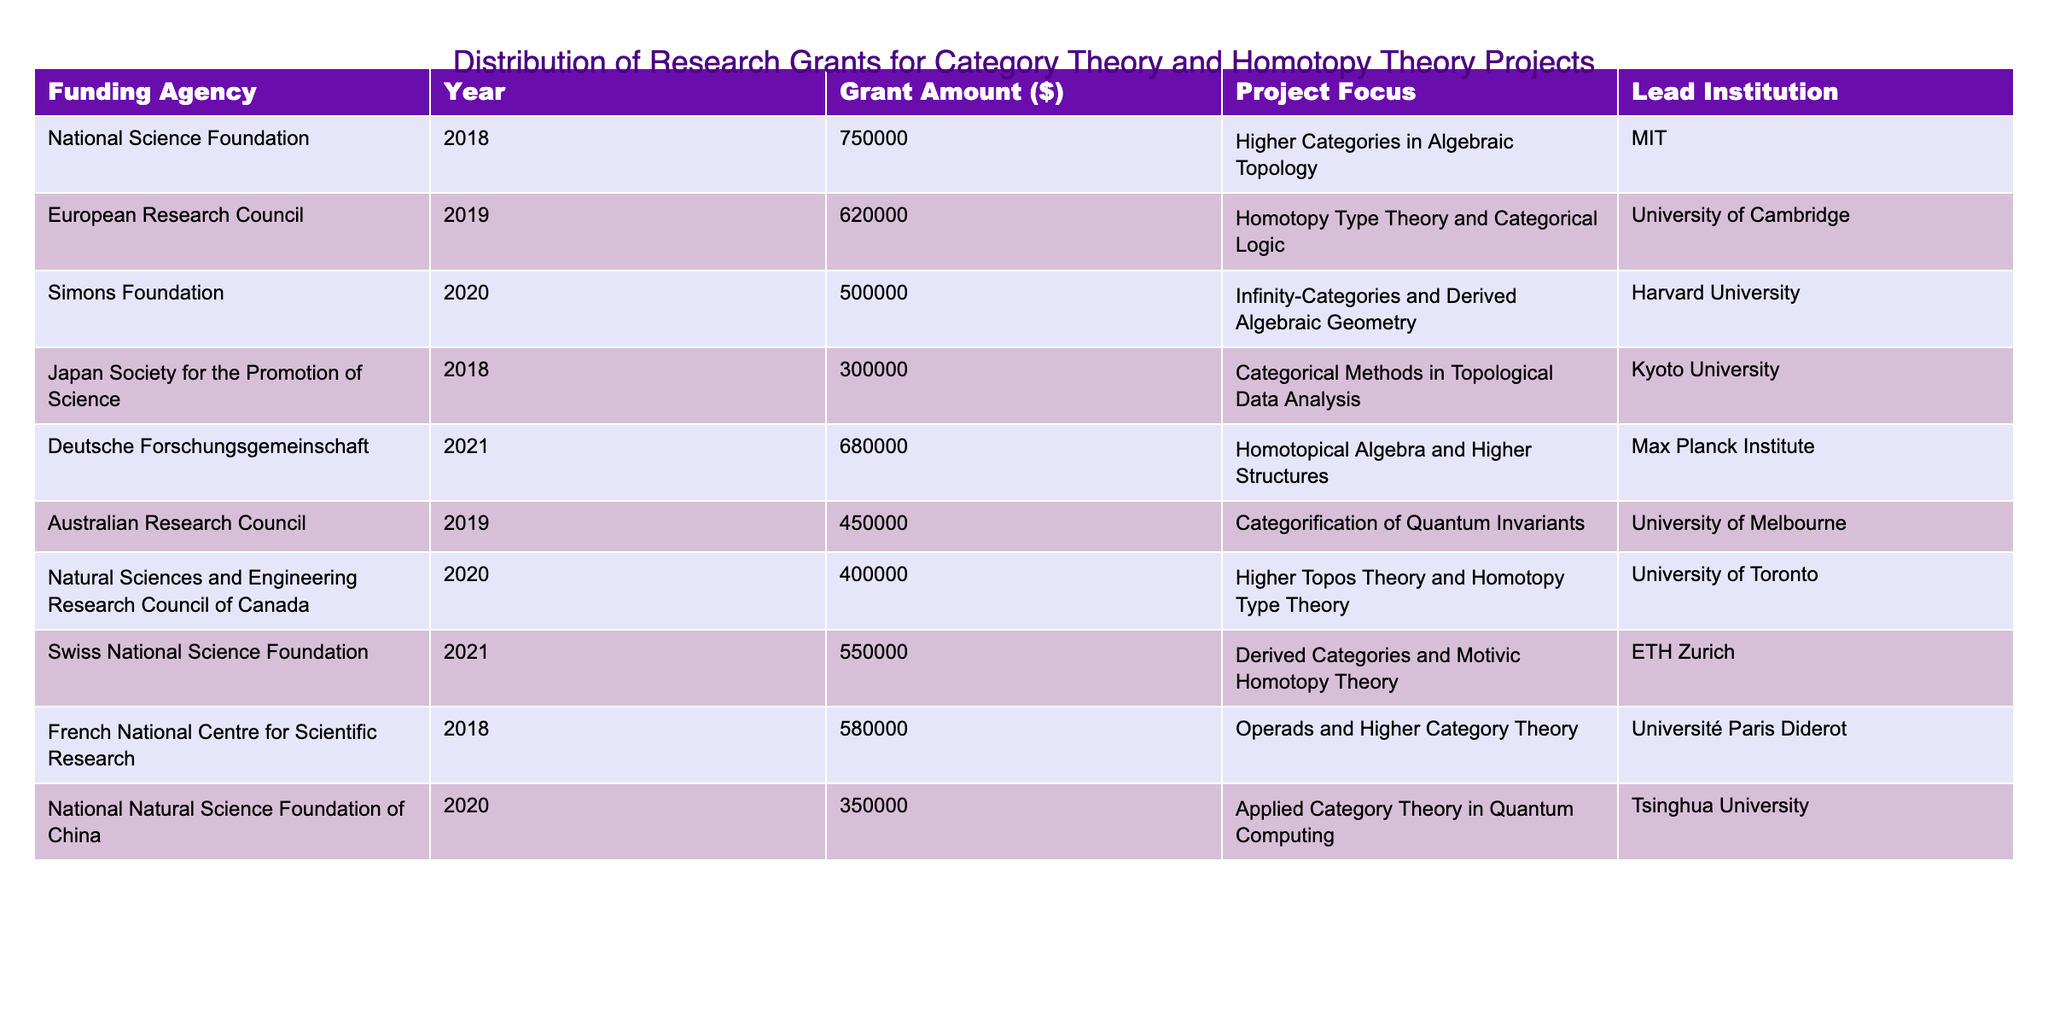What is the highest grant amount listed in the table? The table shows multiple grant amounts. By scanning through the "Grant Amount ($)" column, the highest value is 750000.
Answer: 750000 Which institution received the grant for the project focused on Homotopy Type Theory? The table lists "Homotopy Type Theory and Categorical Logic" under the "Project Focus" column, and looking at the same row, the "Lead Institution" is identified as the University of Cambridge.
Answer: University of Cambridge How many projects involving Higher Categories were funded? In the table, I can find the projects related to Higher Categories in the "Project Focus" column. There are two such entries: "Higher Categories in Algebraic Topology" and "Operads and Higher Category Theory."
Answer: 2 What is the total amount of grants awarded in the year 2020? To find the total grant amount for 2020, I will look at the values in the "Grant Amount ($)" column for that year. They are 500000, 400000, and 350000. Summing these amounts gives 500000 + 400000 + 350000 = 1250000.
Answer: 1250000 Did the National Science Foundation fund a project related to Category Theory? Reviewing the "Funding Agency" and "Project Focus," I see that the National Science Foundation funded "Higher Categories in Algebraic Topology," which is indeed related to Category Theory.
Answer: Yes What is the average grant amount for projects funded by the European Research Council? The table lists one grant from the European Research Council, which is 620000. The average for a single project is simply that value itself, as there are no other grants from this agency.
Answer: 620000 Which project received the lowest grant amount, and what was that amount? Looking through the grant amounts listed in the table, the lowest amount is 300000 for the project focused on "Categorical Methods in Topological Data Analysis."
Answer: Categorical Methods in Topological Data Analysis, 300000 How many different funding agencies are listed in the table? Counting the unique "Funding Agency" entries in the table, I find there are 9 distinct agencies mentioned.
Answer: 9 Which project related to Homotopy Theory has the second highest funding? Reviewing the projects involving Homotopy Theory, we have "Homotopy Type Theory and Categorical Logic" funded at 620000, and "Homotopical Algebra and Higher Structures" at 680000. The second highest is 620000 from the European Research Council.
Answer: 620000 Is there any project funded that involves both Category Theory and Quantum Computing? The project "Applied Category Theory in Quantum Computing" indicates a focus on both areas. Thus, such a project does exist according to the table.
Answer: Yes 